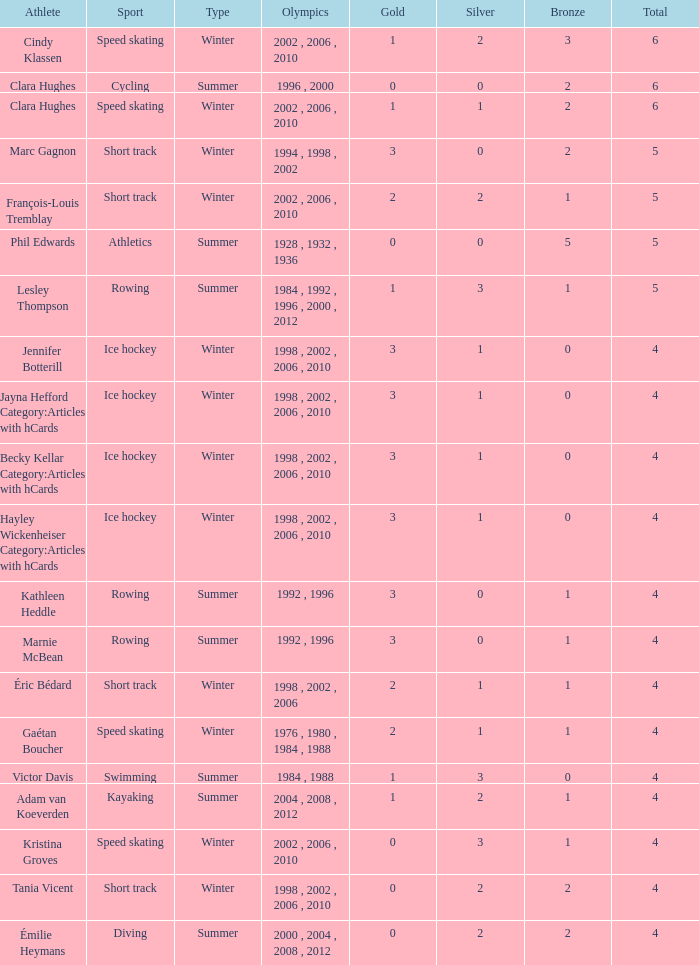What is the average gold of the winter athlete with 1 bronze, less than 3 silver, and less than 4 total medals? None. 